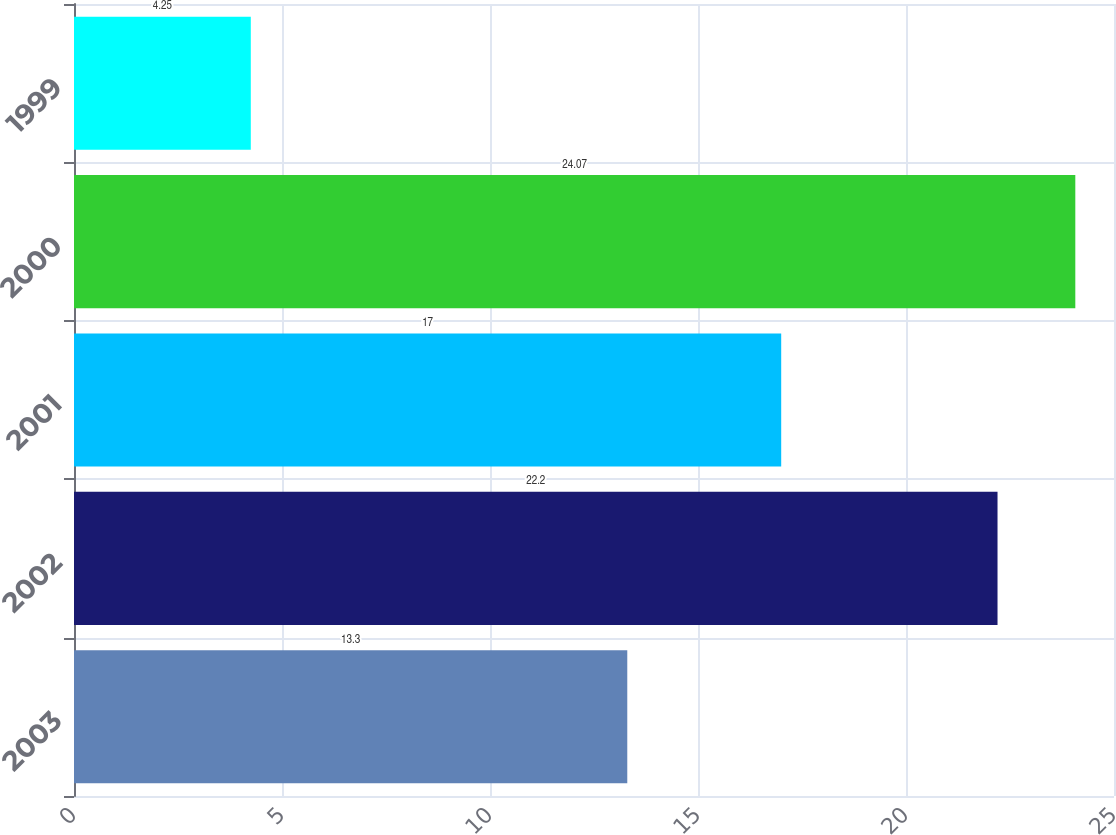Convert chart. <chart><loc_0><loc_0><loc_500><loc_500><bar_chart><fcel>2003<fcel>2002<fcel>2001<fcel>2000<fcel>1999<nl><fcel>13.3<fcel>22.2<fcel>17<fcel>24.07<fcel>4.25<nl></chart> 